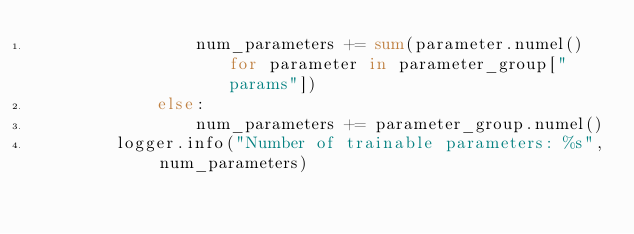Convert code to text. <code><loc_0><loc_0><loc_500><loc_500><_Python_>                num_parameters += sum(parameter.numel() for parameter in parameter_group["params"])
            else:
                num_parameters += parameter_group.numel()
        logger.info("Number of trainable parameters: %s", num_parameters)</code> 